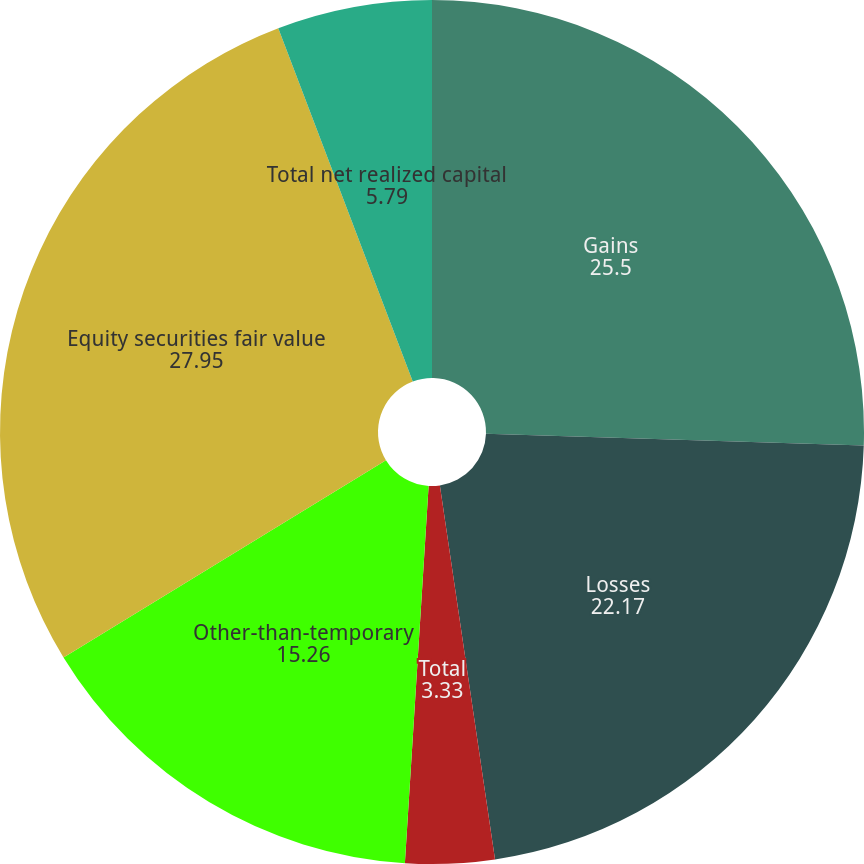Convert chart to OTSL. <chart><loc_0><loc_0><loc_500><loc_500><pie_chart><fcel>Gains<fcel>Losses<fcel>Total<fcel>Other-than-temporary<fcel>Equity securities fair value<fcel>Total net realized capital<nl><fcel>25.5%<fcel>22.17%<fcel>3.33%<fcel>15.26%<fcel>27.95%<fcel>5.79%<nl></chart> 